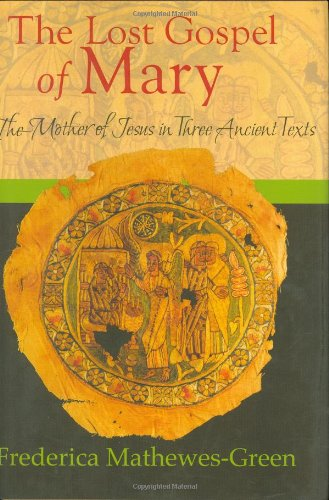How would you describe the artwork on the cover of this book? The cover features a traditional religious icon depicting Mary and Jesus, surrounded by saints. The artwork is rich in gold tones, reflecting the sacred and venerable aspects typically associated with religious icons. 